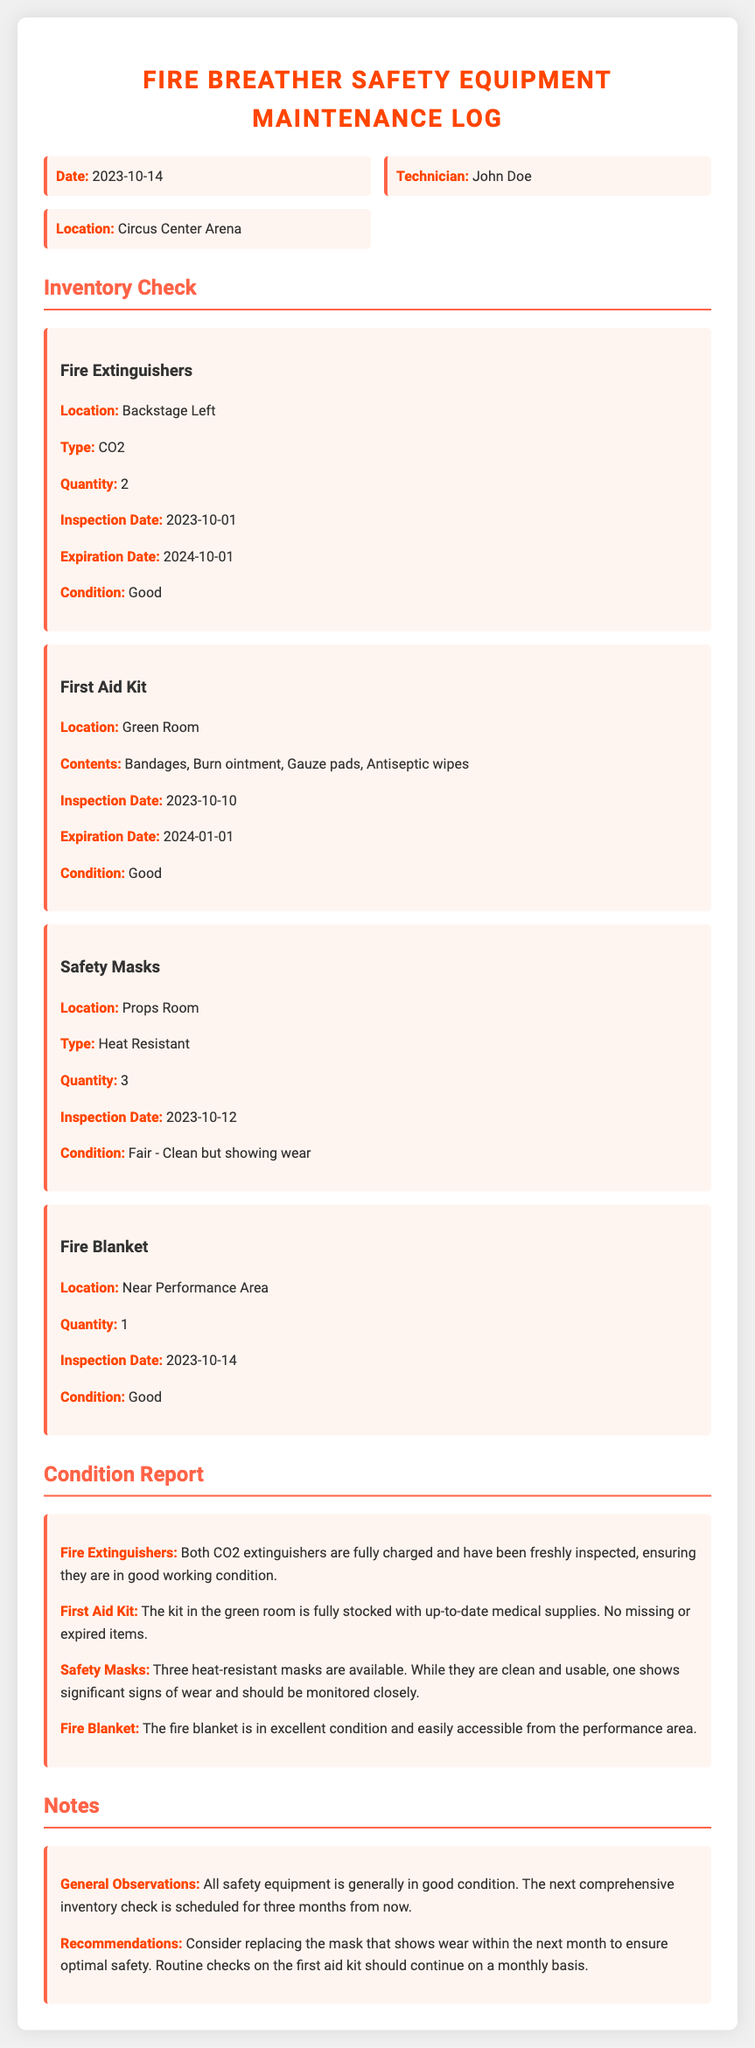What is the date of the inventory check? The date of the inventory check is mentioned at the top of the maintenance log.
Answer: 2023-10-14 Who is the technician responsible for the inspection? The technician's name is stated in the information grid of the document.
Answer: John Doe How many fire extinguishers are available? The quantity of fire extinguishers is indicated in the inventory section for that equipment.
Answer: 2 What is the condition of the safety masks? The condition of the safety masks is described in the condition report section.
Answer: Fair - Clean but showing wear When is the next comprehensive inventory check scheduled? The date for the next inventory check is located in the notes section of the document.
Answer: Three months from now What is the expiration date for the first aid kit? The expiration date for the first aid kit can be found in the inventory check details.
Answer: 2024-01-01 What location is designated for the fire blanket? The location for the fire blanket is specified in the inventory section.
Answer: Near Performance Area What recommendation is made regarding the masks? The recommendation about the masks is articulated in the notes section of the document.
Answer: Consider replacing the mask that shows wear within the next month 